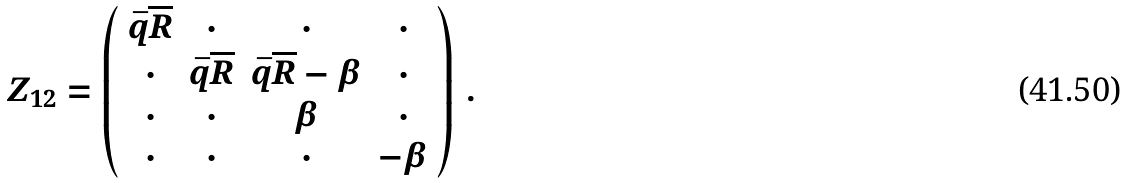<formula> <loc_0><loc_0><loc_500><loc_500>Z _ { 1 2 } = \left ( \begin{array} { c c c c } \bar { q } \overline { R } & \cdot & \cdot & \cdot \\ \cdot & \bar { q } \overline { R } & \bar { q } \overline { R } - \beta & \cdot \\ \cdot & \cdot & \beta & \cdot \\ \cdot & \cdot & \cdot & - \beta \end{array} \right ) \, .</formula> 